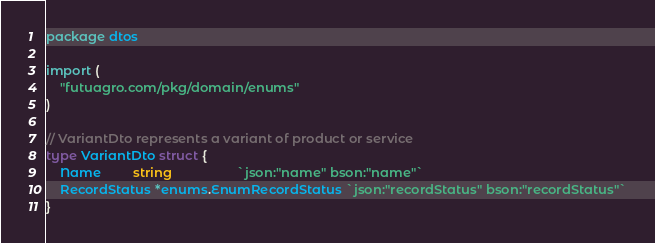<code> <loc_0><loc_0><loc_500><loc_500><_Go_>package dtos

import (
	"futuagro.com/pkg/domain/enums"
)

// VariantDto represents a variant of product or service
type VariantDto struct {
	Name         string                  `json:"name" bson:"name"`
	RecordStatus *enums.EnumRecordStatus `json:"recordStatus" bson:"recordStatus"`
}
</code> 